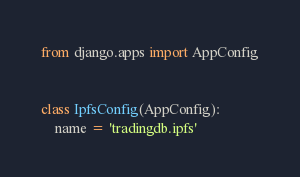Convert code to text. <code><loc_0><loc_0><loc_500><loc_500><_Python_>from django.apps import AppConfig


class IpfsConfig(AppConfig):
    name = 'tradingdb.ipfs'
</code> 